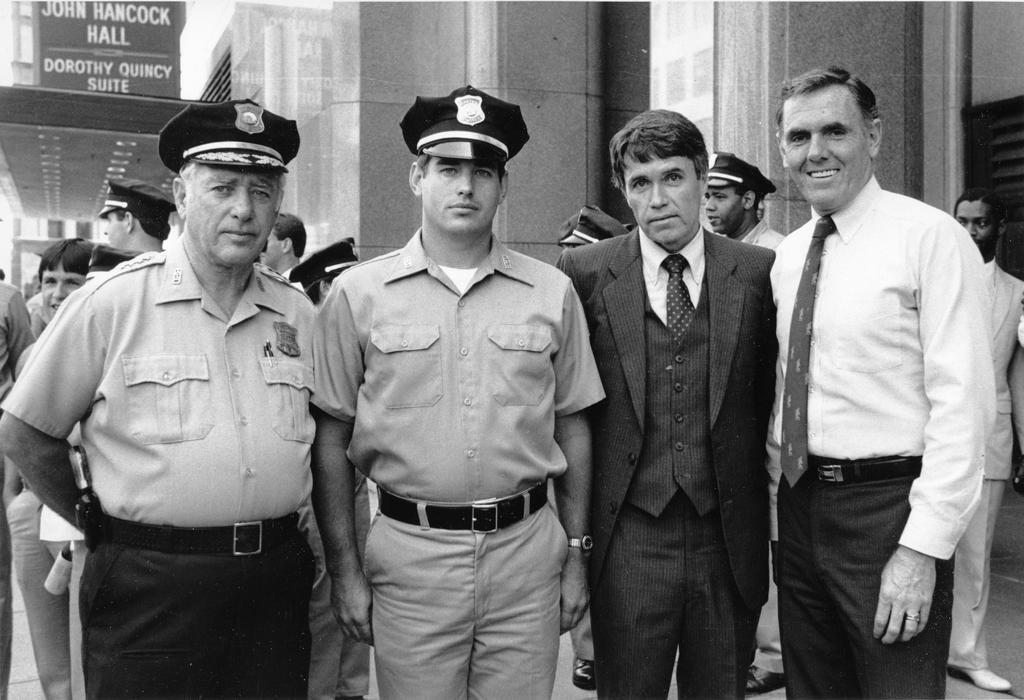Please provide a concise description of this image. In the middle of the image few people are standing and smiling. Behind them few people are standing and there are some buildings. 